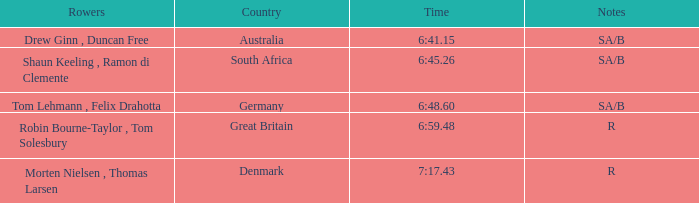What was the time for the rowers representing great britain? 6:59.48. 